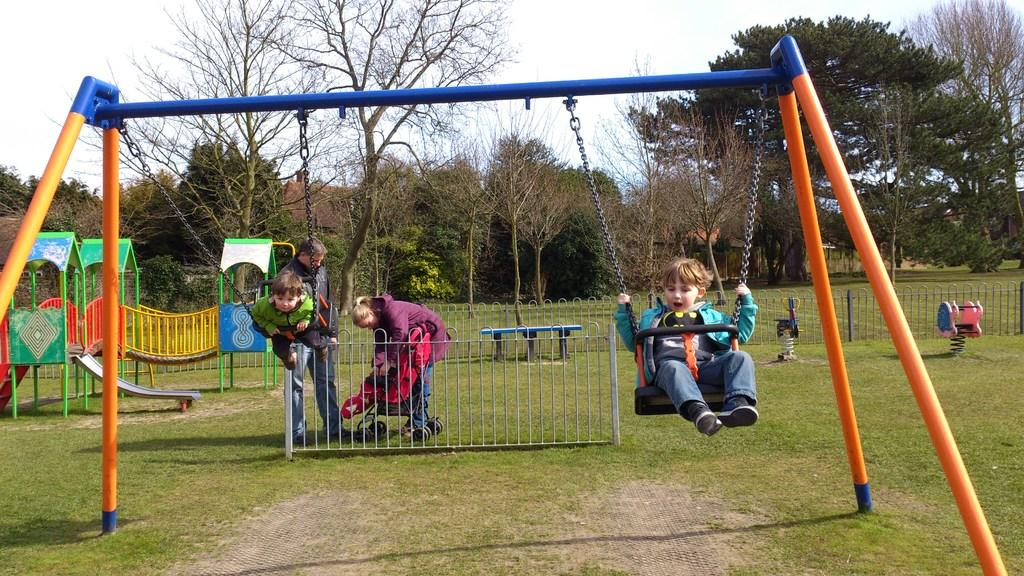What are the two kids doing in the image? The two kids are on the swings. What can be seen in the background of the image? There is a fencing, a slide, trees, and plants visible in the background. What is the surface on which the kids are standing? Grass is present on the floor. What type of heart-shaped object can be seen on the slide in the image? There is no heart-shaped object present on the slide in the image. How many beds are visible in the image? There are no beds visible in the image. 